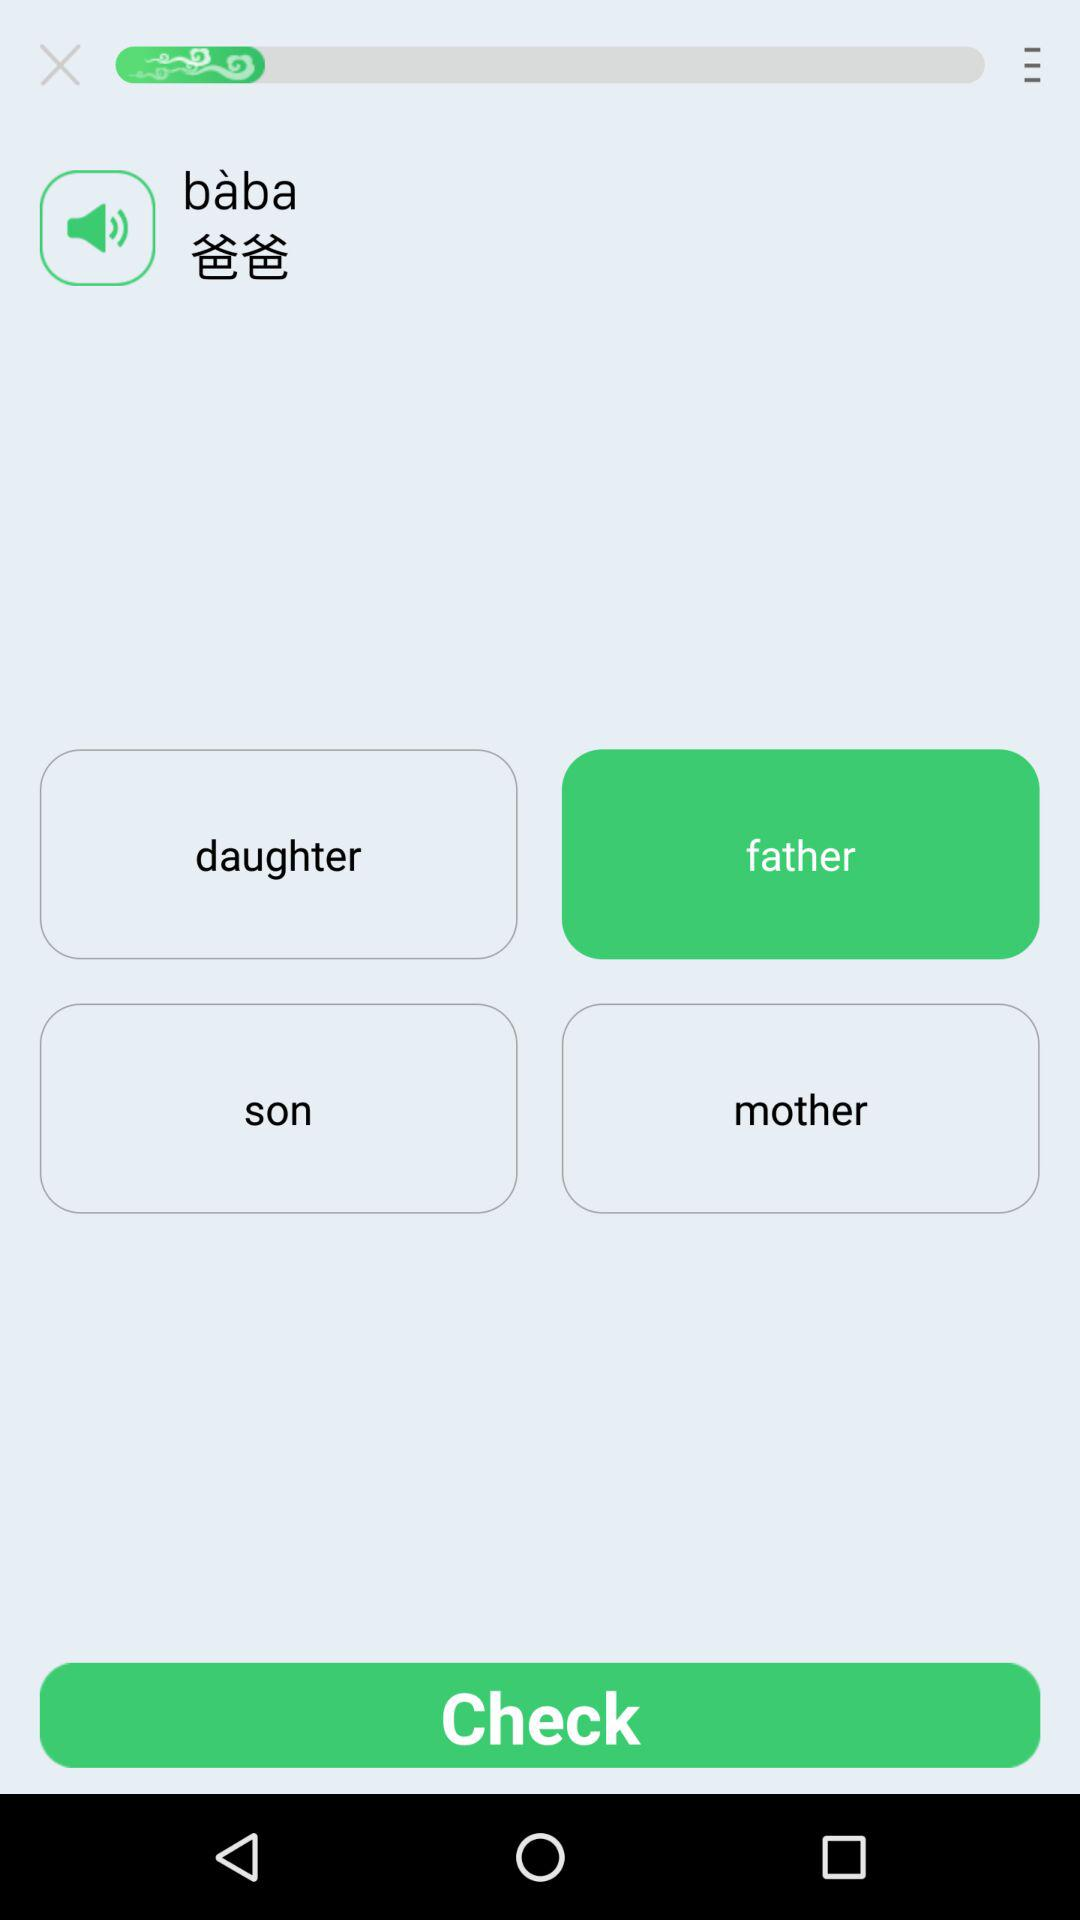Which language is the translation?
When the provided information is insufficient, respond with <no answer>. <no answer> 